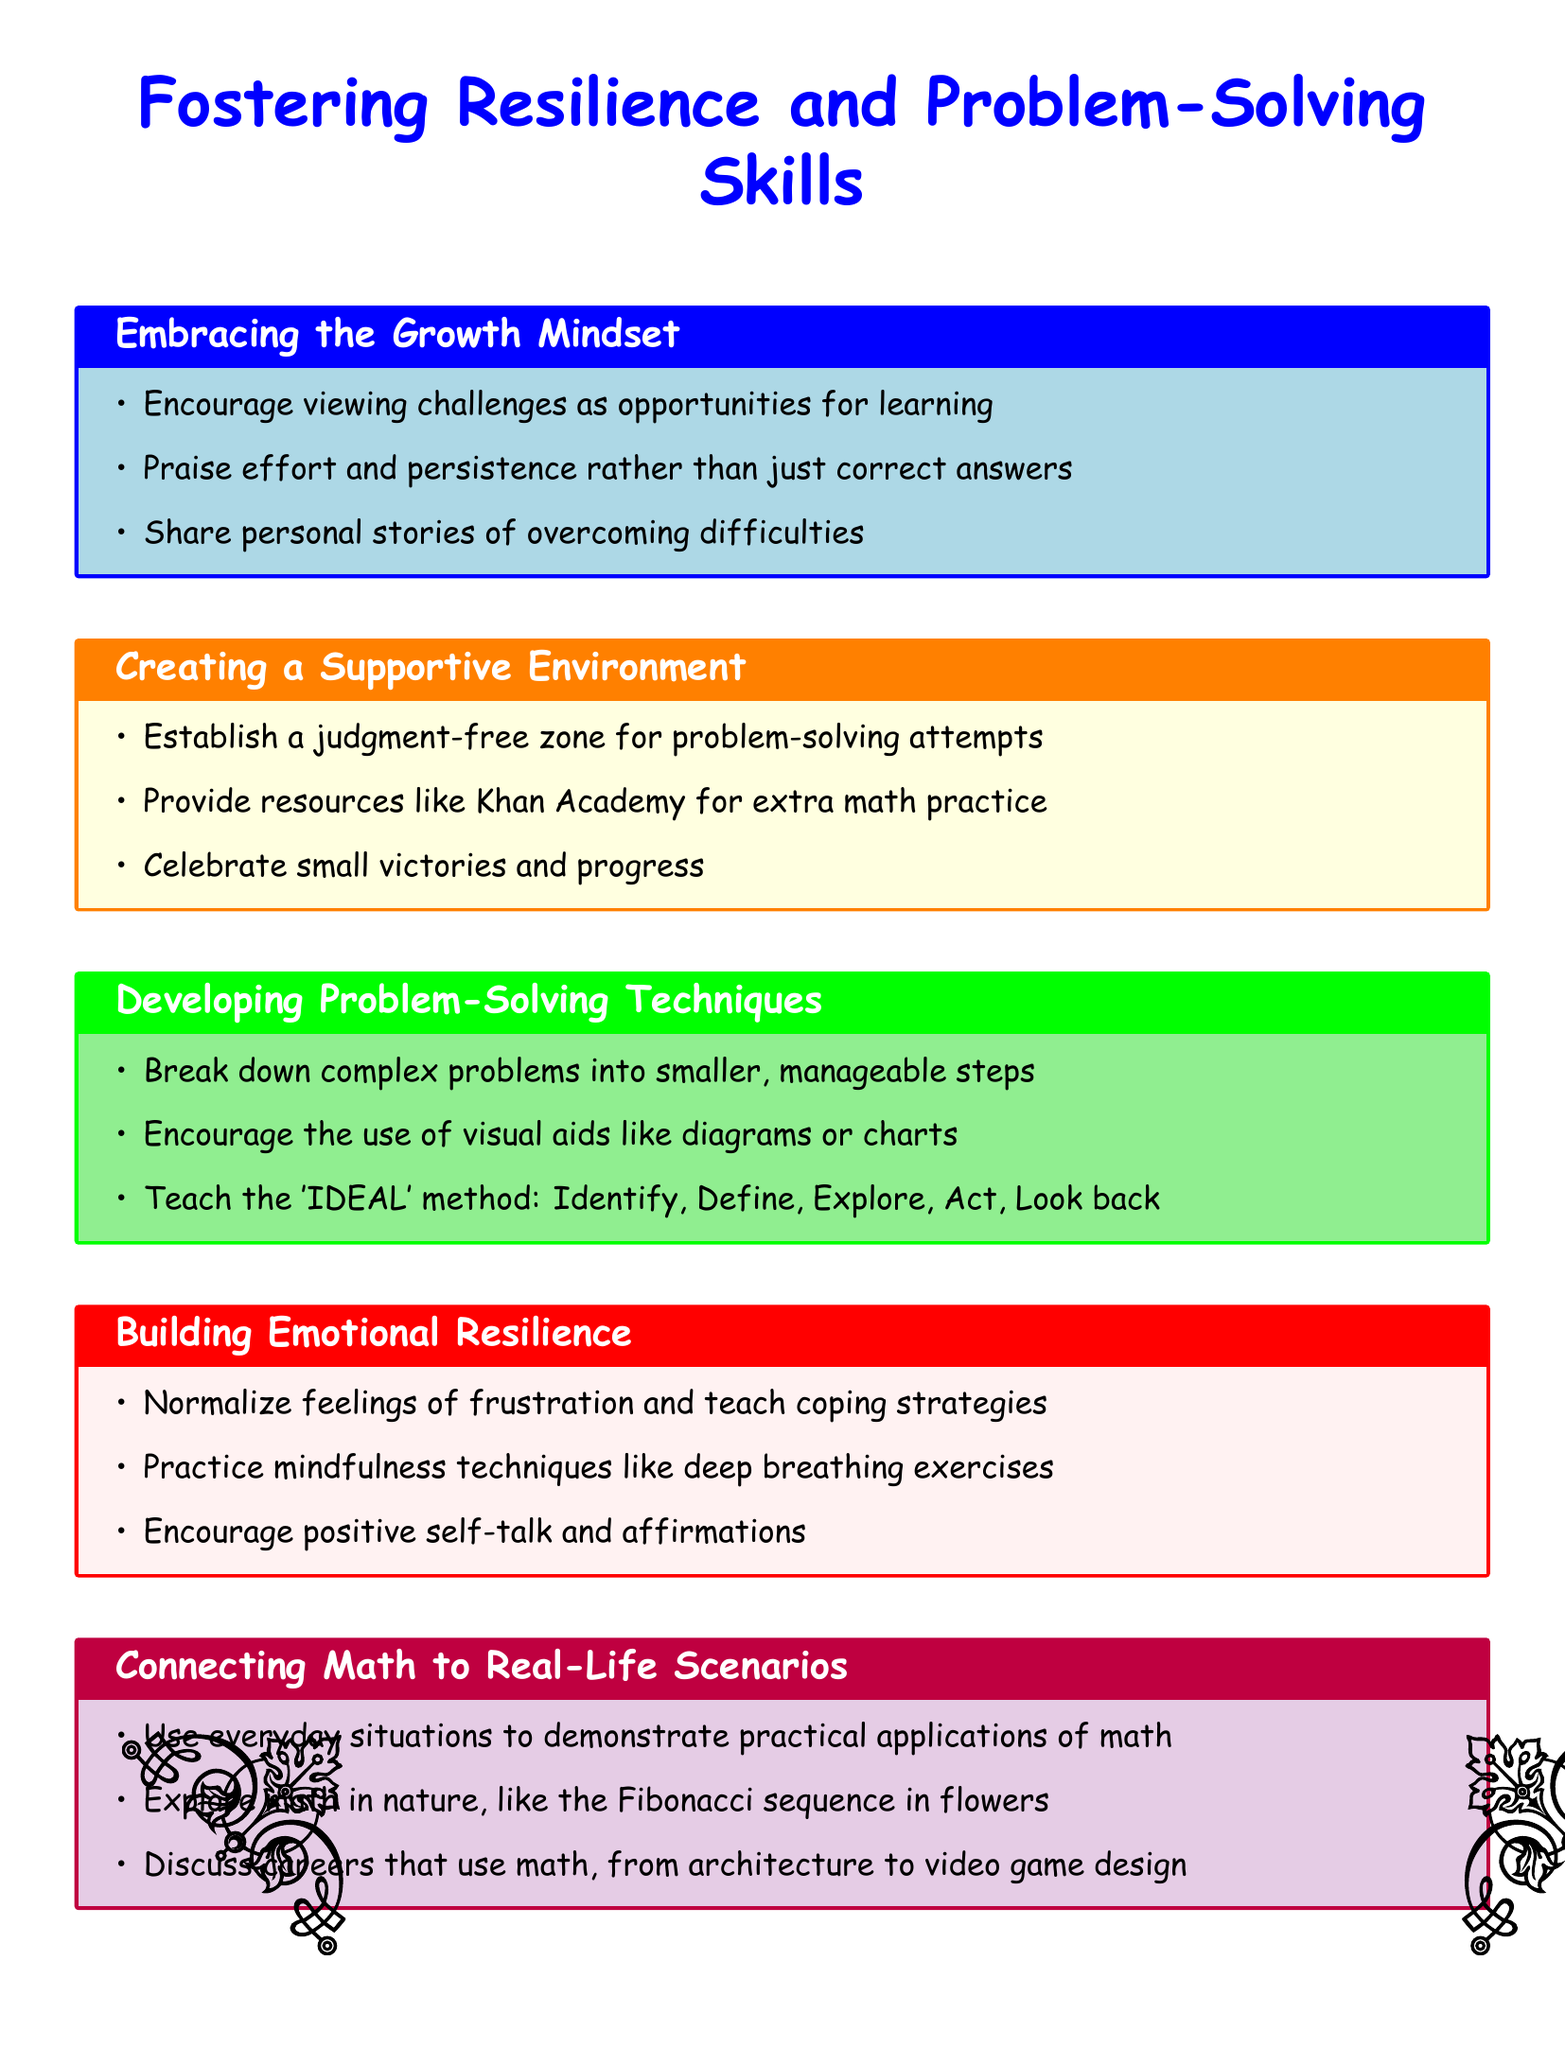What is the title of the document? The title is stated at the beginning of the document, which summarizes the topic covered.
Answer: Fostering Resilience and Problem-Solving Skills How many main sections are there in the document? The document is organized into five distinct sections, each covering a different aspect of the topic.
Answer: 5 What is the main focus of the section titled "Building Emotional Resilience"? The section outlines strategies to help individuals cope with emotions and frustrations while problem-solving.
Answer: Coping strategies What method is suggested for developing problem-solving skills? The document mentions a specific method for guiding problem-solving that involves several strategic steps.
Answer: IDEAL method What kind of environment is recommended for problem-solving? The document emphasizes the importance of creating a space where individuals feel safe to attempt solving problems without judgment.
Answer: Judgment-free zone Which personal strategy is highlighted to deal with frustration? The document suggests techniques that help manage feelings of frustration during challenging tasks.
Answer: Coping strategies In which section can you find the advice to celebrate small victories? This advice is located within a section that focuses on creating a supportive atmosphere during learning.
Answer: Creating a Supportive Environment What is one real-life connection made to math in the document? The document provides examples of how math is applicable in practical contexts outside of academic settings.
Answer: Fibonacci sequence in flowers 